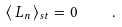<formula> <loc_0><loc_0><loc_500><loc_500>\langle \, L _ { n } \, \rangle _ { s t } = 0 \quad .</formula> 